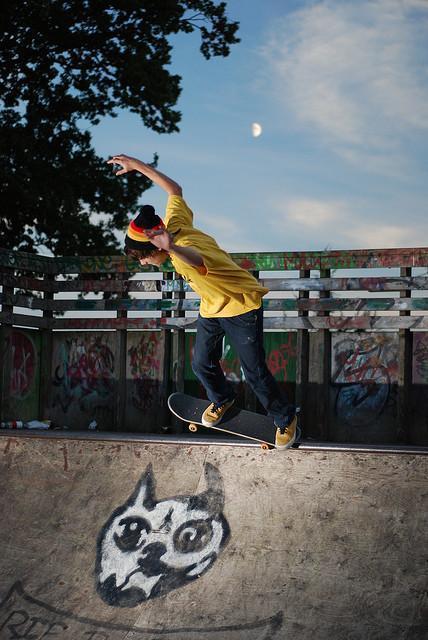How many ducks have orange hats?
Give a very brief answer. 0. 